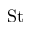<formula> <loc_0><loc_0><loc_500><loc_500>S t</formula> 